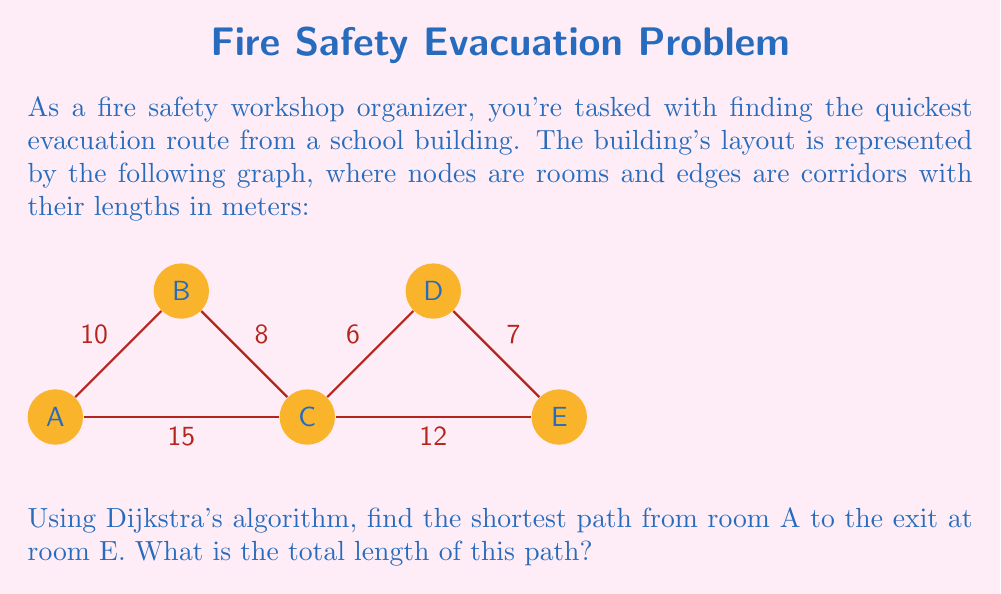Can you answer this question? Let's apply Dijkstra's algorithm to find the shortest path from A to E:

1) Initialize:
   - Distance to A: 0
   - Distance to all other nodes: ∞
   - Set of unvisited nodes: {A, B, C, D, E}

2) From A:
   - Update: d(C) = min(∞, 0 + 15) = 15
   - Update: d(B) = min(∞, 0 + 10) = 10
   - Mark A as visited

3) Select B (smallest distance among unvisited):
   - Update: d(C) = min(15, 10 + 8) = 15
   - Update: d(D) = min(∞, 10 + 14) = 24
   - Mark B as visited

4) Select C:
   - Update: d(D) = min(24, 15 + 6) = 21
   - Update: d(E) = min(∞, 15 + 12) = 27
   - Mark C as visited

5) Select D:
   - Update: d(E) = min(27, 21 + 7) = 27
   - Mark D as visited

6) Select E (only remaining node):
   - Mark E as visited

The shortest path is A → C → E with a total length of 27 meters.
Answer: 27 meters 